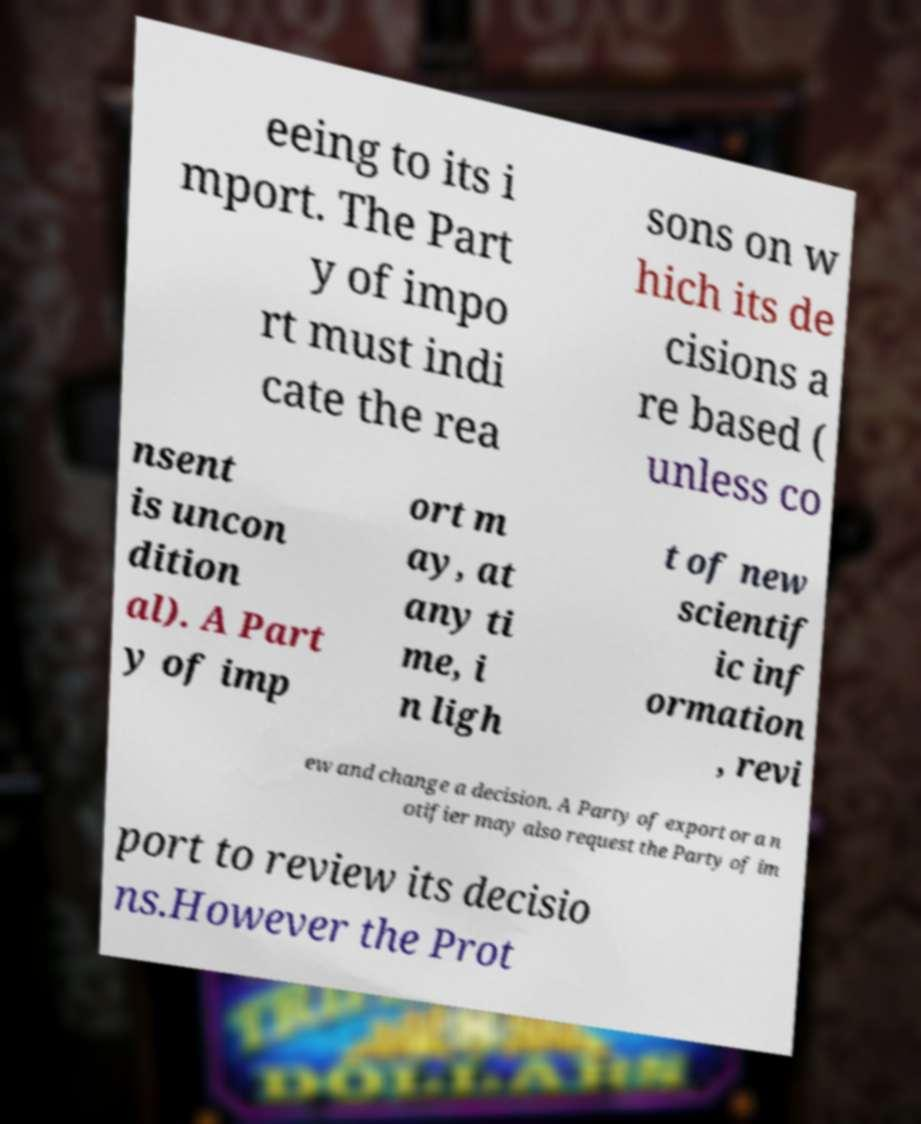For documentation purposes, I need the text within this image transcribed. Could you provide that? eeing to its i mport. The Part y of impo rt must indi cate the rea sons on w hich its de cisions a re based ( unless co nsent is uncon dition al). A Part y of imp ort m ay, at any ti me, i n ligh t of new scientif ic inf ormation , revi ew and change a decision. A Party of export or a n otifier may also request the Party of im port to review its decisio ns.However the Prot 